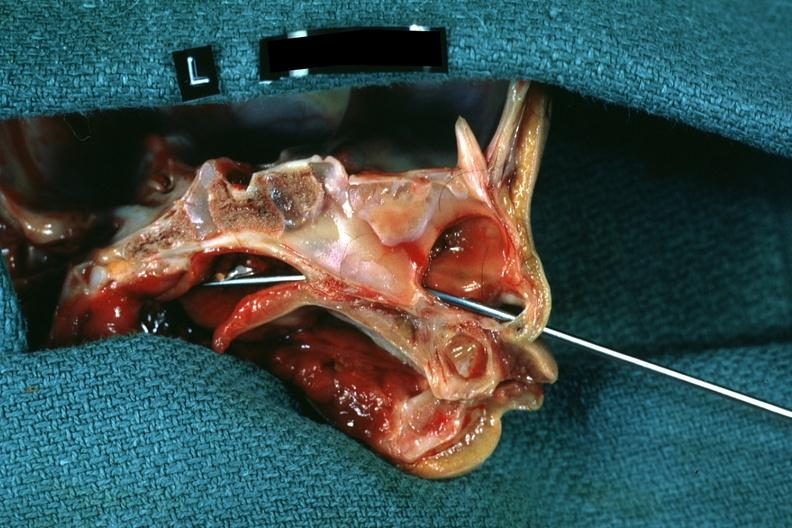what is present?
Answer the question using a single word or phrase. Choanal patency 